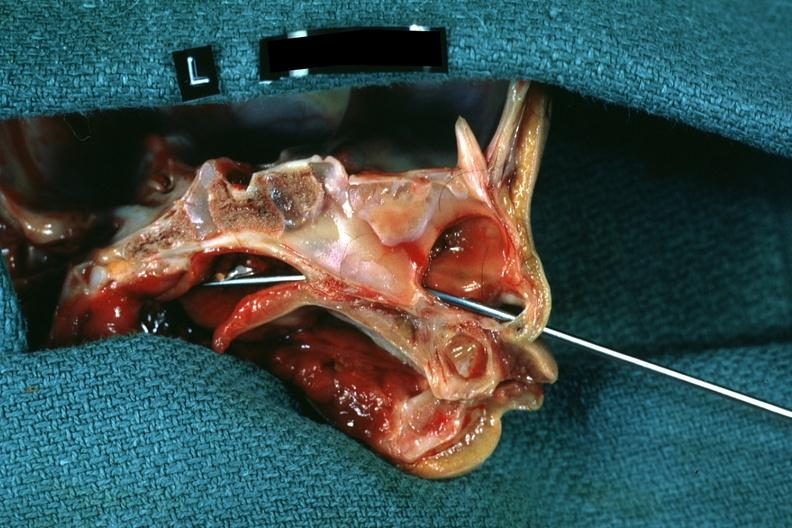what is present?
Answer the question using a single word or phrase. Choanal patency 